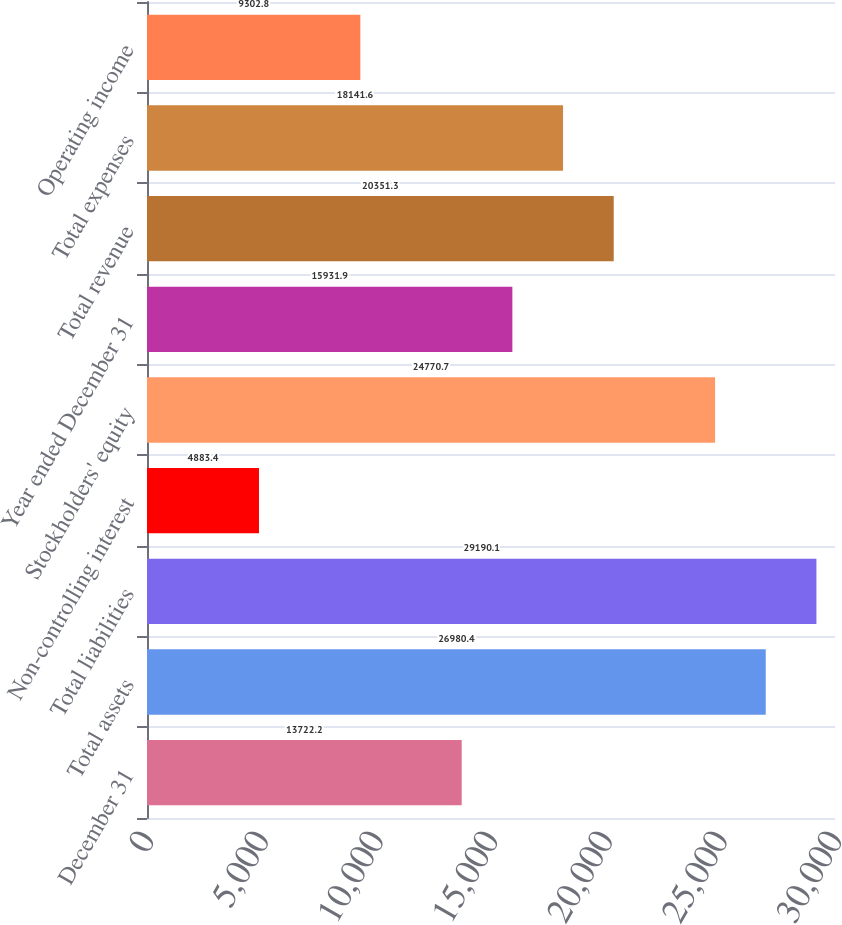Convert chart to OTSL. <chart><loc_0><loc_0><loc_500><loc_500><bar_chart><fcel>December 31<fcel>Total assets<fcel>Total liabilities<fcel>Non-controlling interest<fcel>Stockholders' equity<fcel>Year ended December 31<fcel>Total revenue<fcel>Total expenses<fcel>Operating income<nl><fcel>13722.2<fcel>26980.4<fcel>29190.1<fcel>4883.4<fcel>24770.7<fcel>15931.9<fcel>20351.3<fcel>18141.6<fcel>9302.8<nl></chart> 